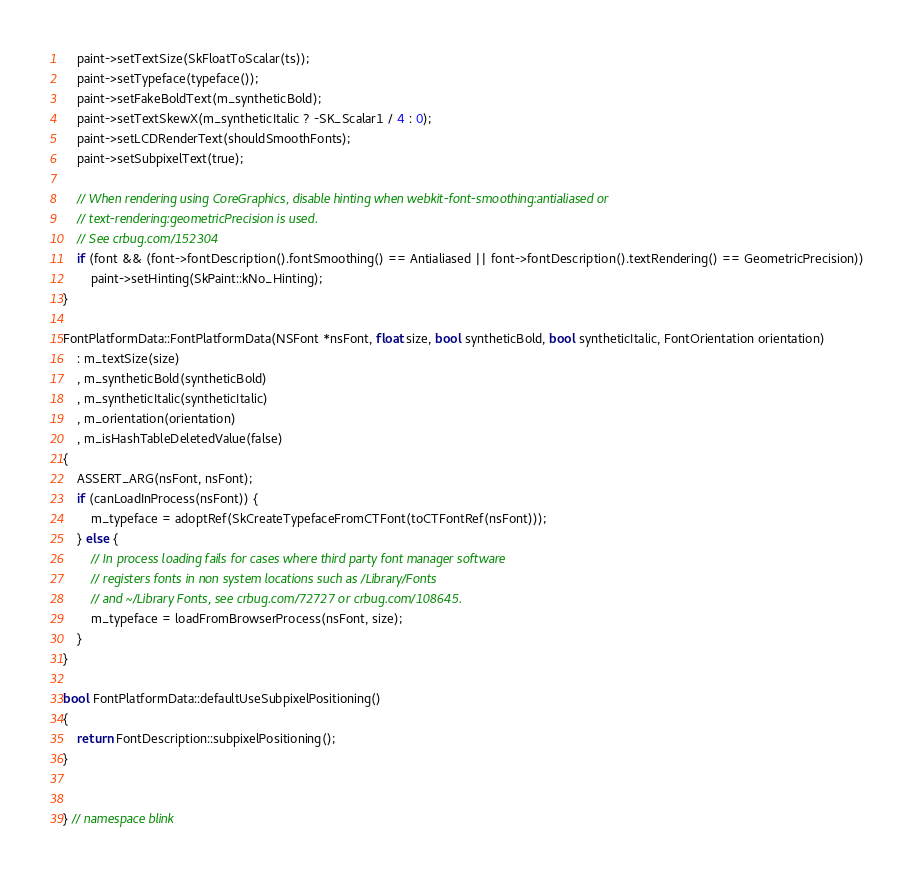Convert code to text. <code><loc_0><loc_0><loc_500><loc_500><_ObjectiveC_>    paint->setTextSize(SkFloatToScalar(ts));
    paint->setTypeface(typeface());
    paint->setFakeBoldText(m_syntheticBold);
    paint->setTextSkewX(m_syntheticItalic ? -SK_Scalar1 / 4 : 0);
    paint->setLCDRenderText(shouldSmoothFonts);
    paint->setSubpixelText(true);

    // When rendering using CoreGraphics, disable hinting when webkit-font-smoothing:antialiased or
    // text-rendering:geometricPrecision is used.
    // See crbug.com/152304
    if (font && (font->fontDescription().fontSmoothing() == Antialiased || font->fontDescription().textRendering() == GeometricPrecision))
        paint->setHinting(SkPaint::kNo_Hinting);
}

FontPlatformData::FontPlatformData(NSFont *nsFont, float size, bool syntheticBold, bool syntheticItalic, FontOrientation orientation)
    : m_textSize(size)
    , m_syntheticBold(syntheticBold)
    , m_syntheticItalic(syntheticItalic)
    , m_orientation(orientation)
    , m_isHashTableDeletedValue(false)
{
    ASSERT_ARG(nsFont, nsFont);
    if (canLoadInProcess(nsFont)) {
        m_typeface = adoptRef(SkCreateTypefaceFromCTFont(toCTFontRef(nsFont)));
    } else {
        // In process loading fails for cases where third party font manager software
        // registers fonts in non system locations such as /Library/Fonts
        // and ~/Library Fonts, see crbug.com/72727 or crbug.com/108645.
        m_typeface = loadFromBrowserProcess(nsFont, size);
    }
}

bool FontPlatformData::defaultUseSubpixelPositioning()
{
    return FontDescription::subpixelPositioning();
}


} // namespace blink
</code> 